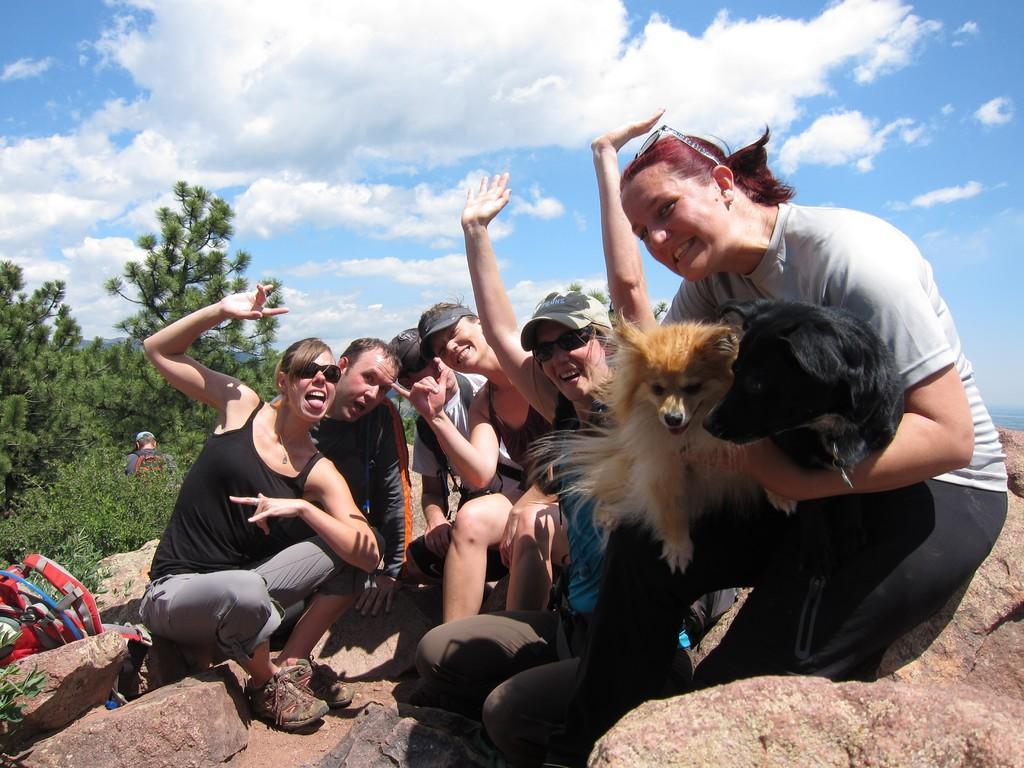Could you give a brief overview of what you see in this image? There is a group of people sitting on the rocks in this picture. There are two dogs in the hands of a woman sitting in the right side. We can observe some trees and a clouds in the sky in the background. 